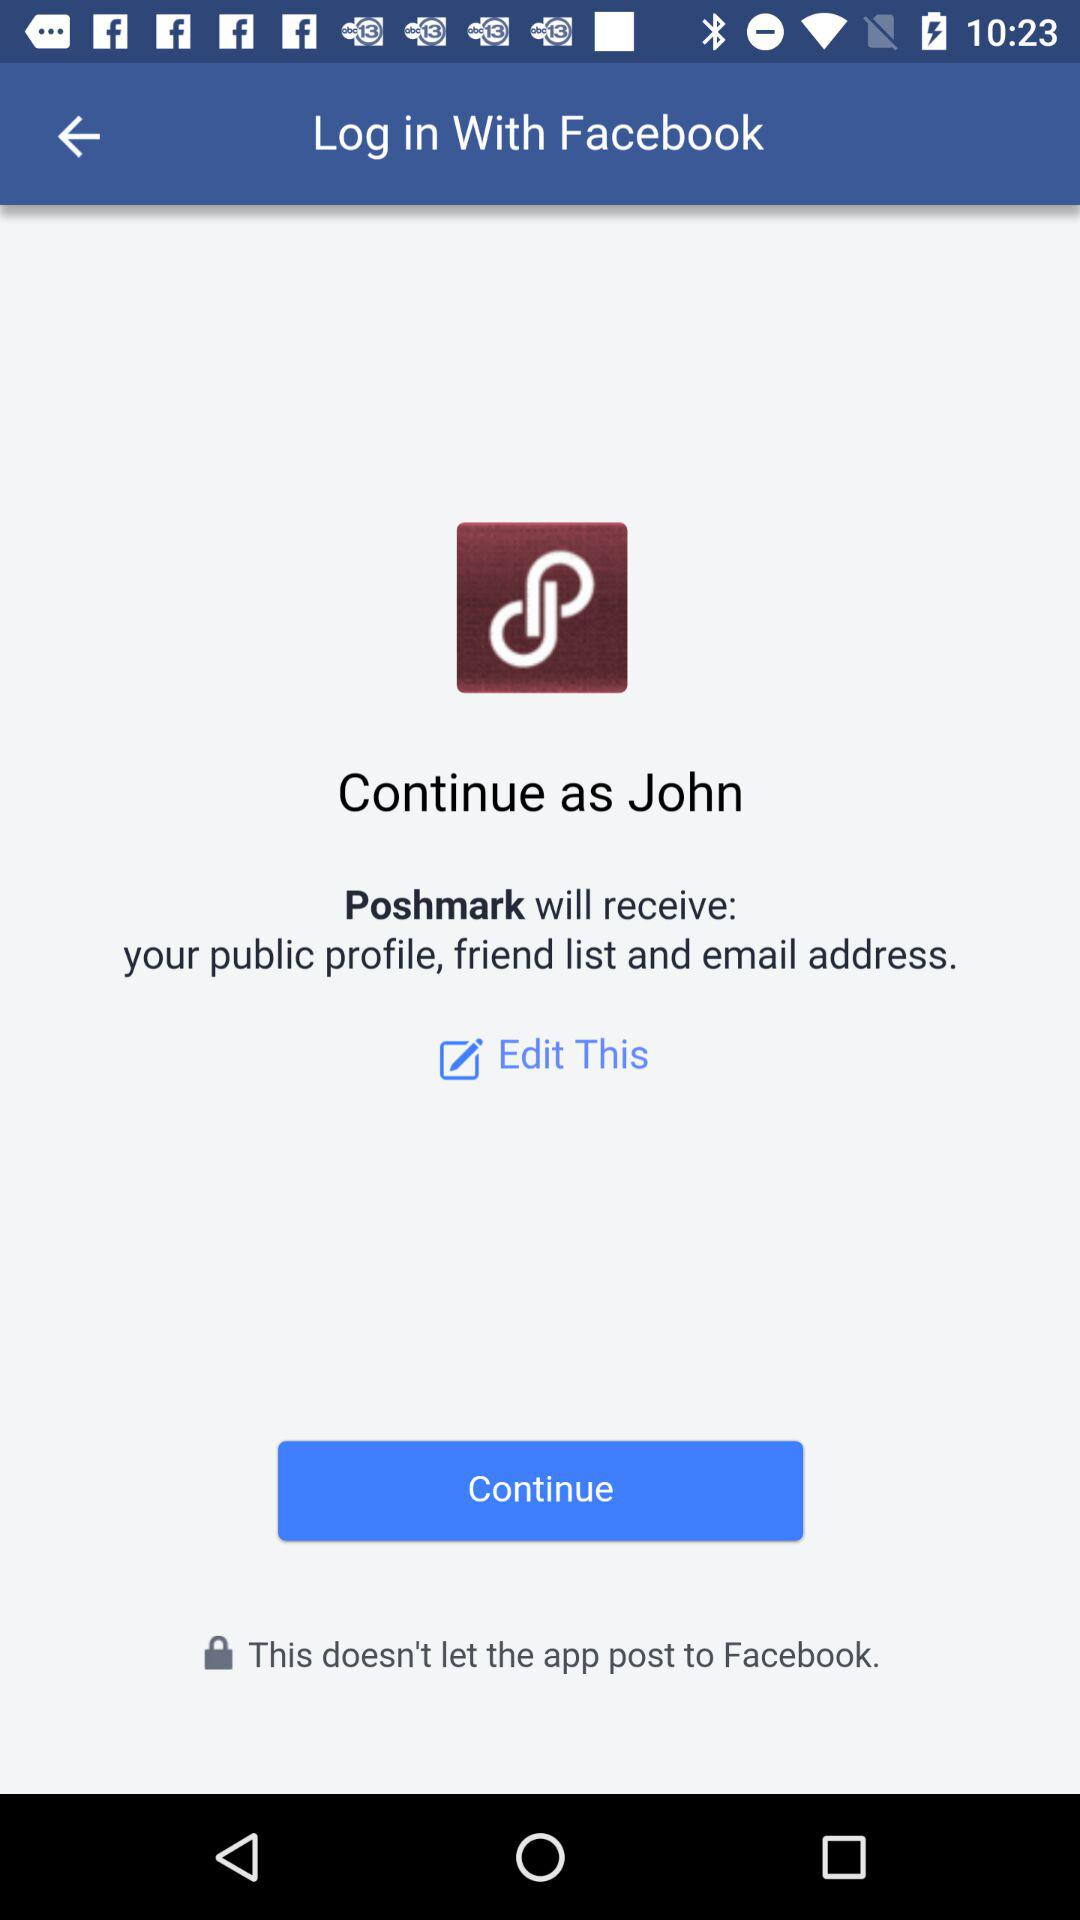What application is asking for permission? The application is "Poshmark". 